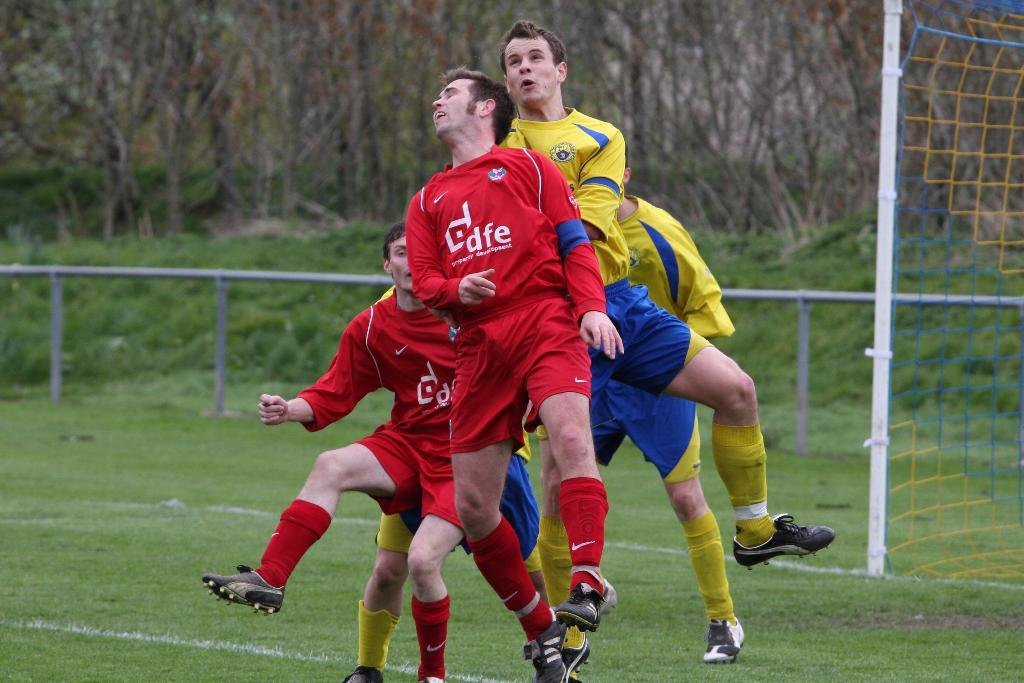<image>
Create a compact narrative representing the image presented. A soccer player has the letters dfe on his jersey. 